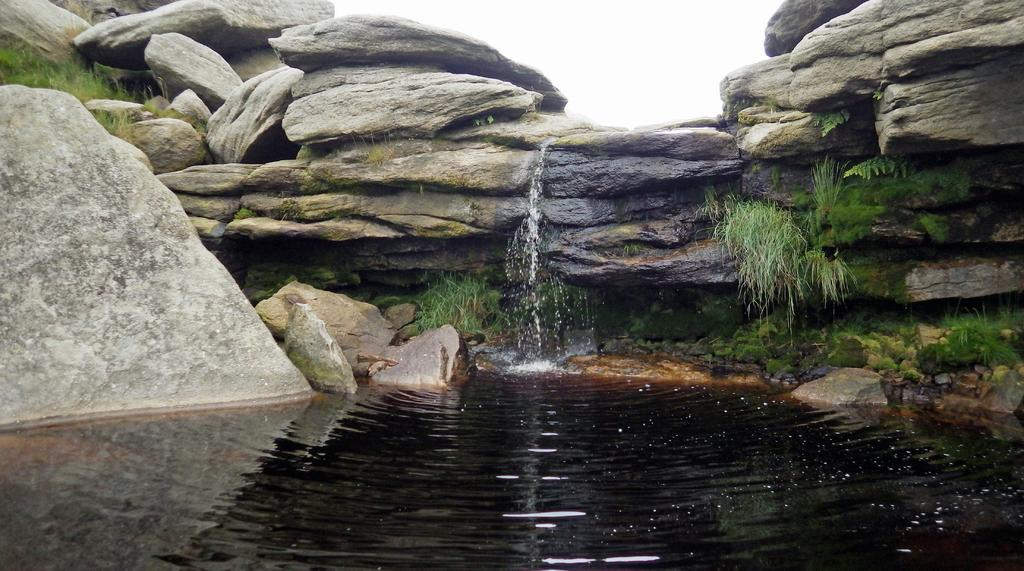What is located in the middle of the image? There is water in the middle of the image. What is behind the water in the image? There are stones stacked one above the other behind the water. What can be seen on the left side of the image? There is a big rock on the left side of the image. What type of vegetation is growing on the stones? Grass is growing on the stones. How many committee members are present in the image? There is no committee or committee members present in the image. What type of zephyr can be seen blowing through the grass in the image? There is no zephyr present in the image; it is a still scene with no wind or breeze visible. 